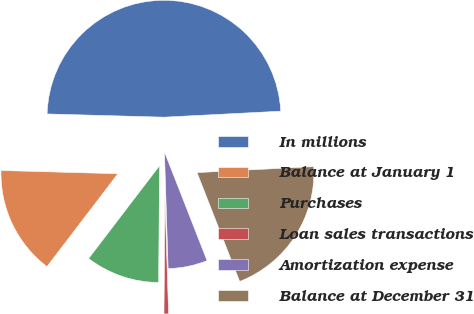Convert chart. <chart><loc_0><loc_0><loc_500><loc_500><pie_chart><fcel>In millions<fcel>Balance at January 1<fcel>Purchases<fcel>Loan sales transactions<fcel>Amortization expense<fcel>Balance at December 31<nl><fcel>48.74%<fcel>15.06%<fcel>10.25%<fcel>0.63%<fcel>5.44%<fcel>19.87%<nl></chart> 